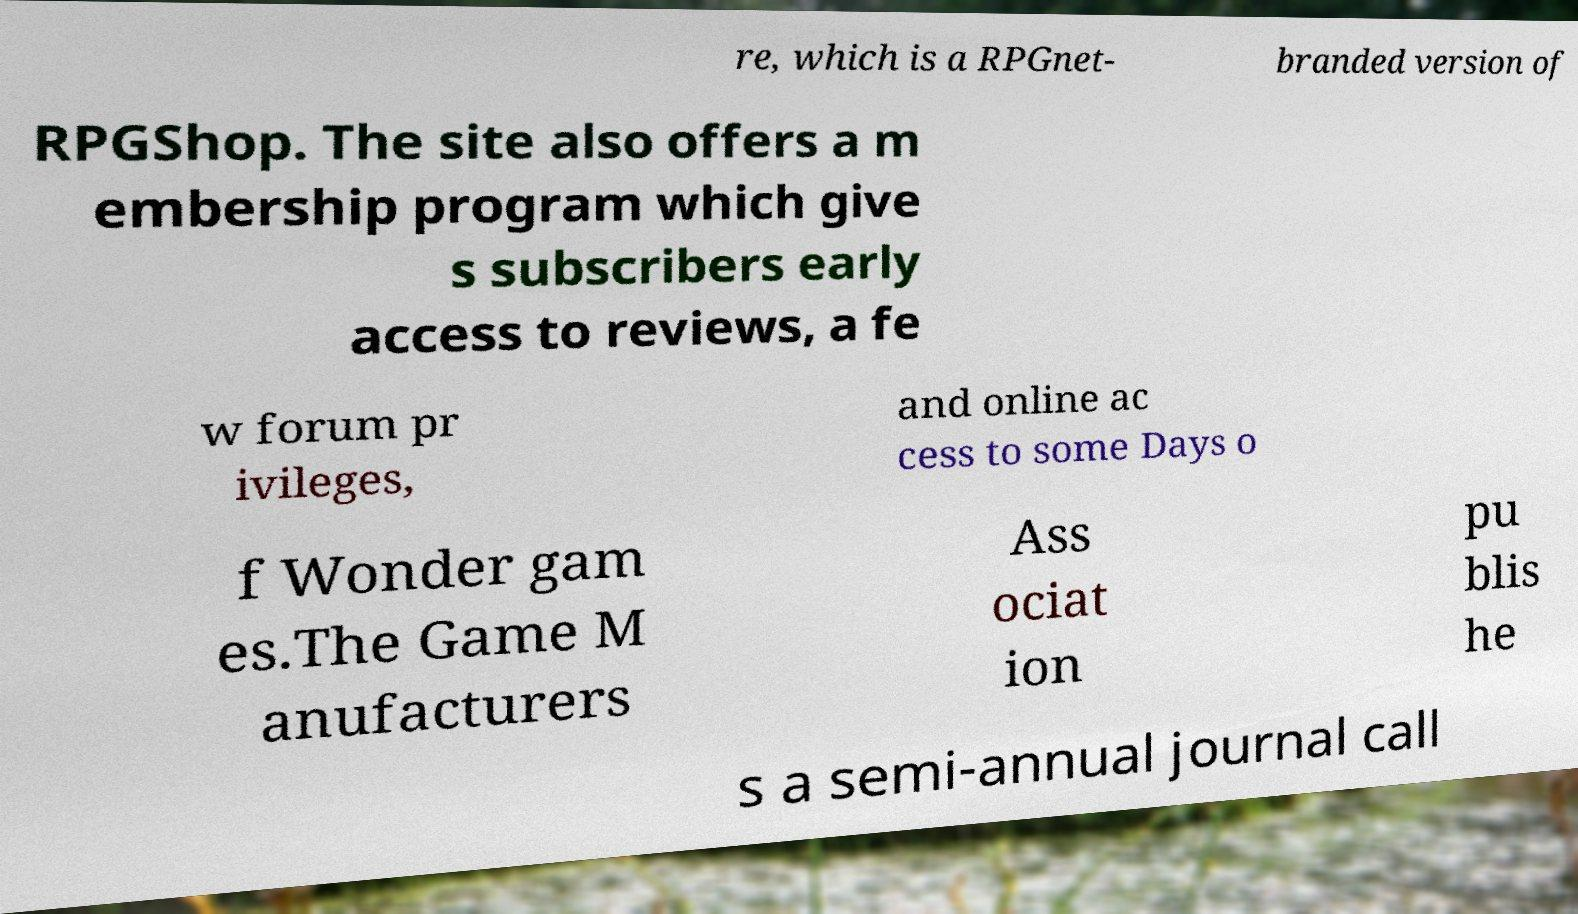What messages or text are displayed in this image? I need them in a readable, typed format. re, which is a RPGnet- branded version of RPGShop. The site also offers a m embership program which give s subscribers early access to reviews, a fe w forum pr ivileges, and online ac cess to some Days o f Wonder gam es.The Game M anufacturers Ass ociat ion pu blis he s a semi-annual journal call 